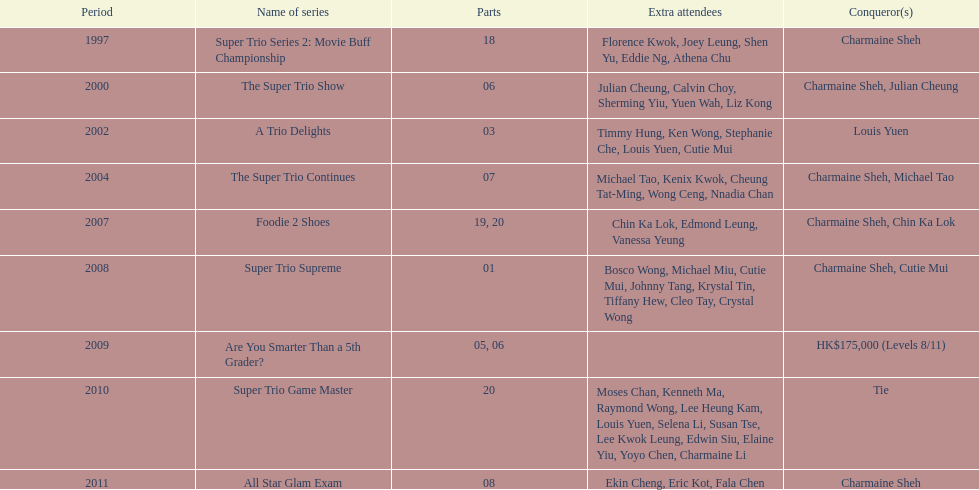How many times has charmaine sheh won on a variety show? 6. Could you help me parse every detail presented in this table? {'header': ['Period', 'Name of series', 'Parts', 'Extra attendees', 'Conqueror(s)'], 'rows': [['1997', 'Super Trio Series 2: Movie Buff Championship', '18', 'Florence Kwok, Joey Leung, Shen Yu, Eddie Ng, Athena Chu', 'Charmaine Sheh'], ['2000', 'The Super Trio Show', '06', 'Julian Cheung, Calvin Choy, Sherming Yiu, Yuen Wah, Liz Kong', 'Charmaine Sheh, Julian Cheung'], ['2002', 'A Trio Delights', '03', 'Timmy Hung, Ken Wong, Stephanie Che, Louis Yuen, Cutie Mui', 'Louis Yuen'], ['2004', 'The Super Trio Continues', '07', 'Michael Tao, Kenix Kwok, Cheung Tat-Ming, Wong Ceng, Nnadia Chan', 'Charmaine Sheh, Michael Tao'], ['2007', 'Foodie 2 Shoes', '19, 20', 'Chin Ka Lok, Edmond Leung, Vanessa Yeung', 'Charmaine Sheh, Chin Ka Lok'], ['2008', 'Super Trio Supreme', '01', 'Bosco Wong, Michael Miu, Cutie Mui, Johnny Tang, Krystal Tin, Tiffany Hew, Cleo Tay, Crystal Wong', 'Charmaine Sheh, Cutie Mui'], ['2009', 'Are You Smarter Than a 5th Grader?', '05, 06', '', 'HK$175,000 (Levels 8/11)'], ['2010', 'Super Trio Game Master', '20', 'Moses Chan, Kenneth Ma, Raymond Wong, Lee Heung Kam, Louis Yuen, Selena Li, Susan Tse, Lee Kwok Leung, Edwin Siu, Elaine Yiu, Yoyo Chen, Charmaine Li', 'Tie'], ['2011', 'All Star Glam Exam', '08', 'Ekin Cheng, Eric Kot, Fala Chen', 'Charmaine Sheh']]} 